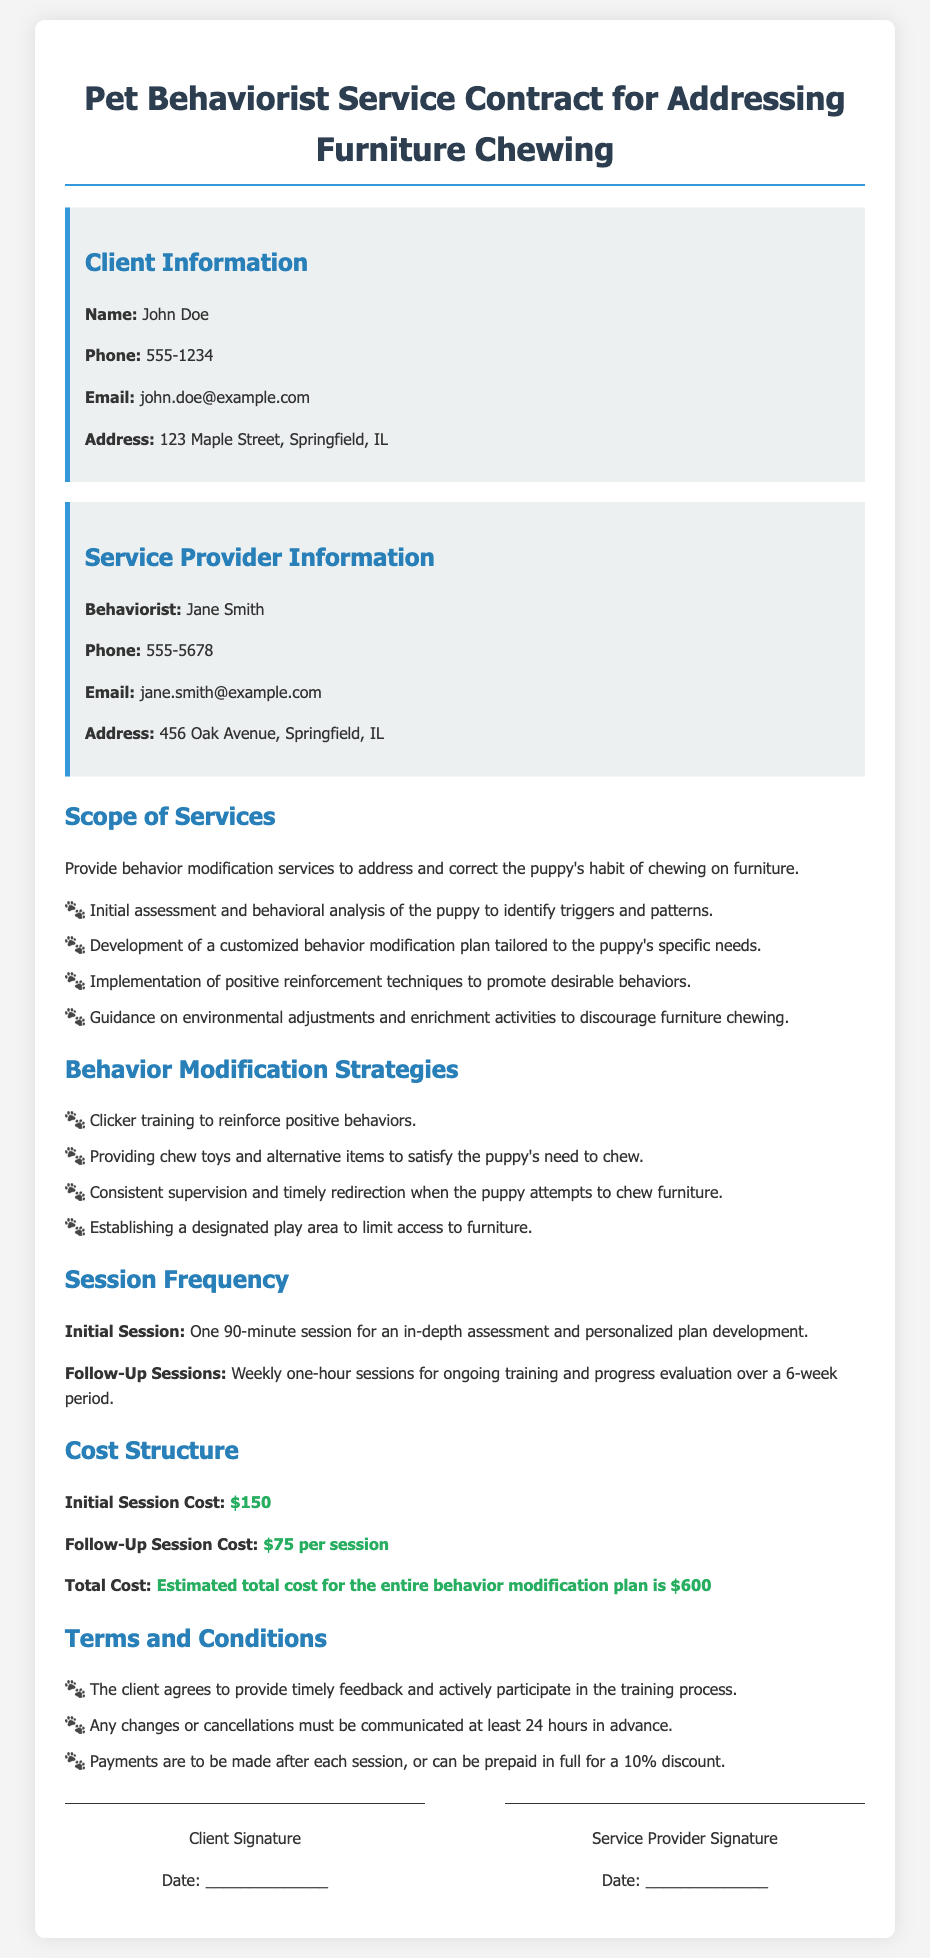What is the name of the client? The client's name is mentioned in the document under Client Information.
Answer: John Doe Who is the service provider? The service provider is listed in the Service Provider Information section of the document.
Answer: Jane Smith How many follow-up sessions are included in the plan? The number of follow-up sessions is specified in the Session Frequency section of the document.
Answer: 6 What is the cost of the initial session? The cost of the initial session is found in the Cost Structure section of the document.
Answer: $150 What type of training method is mentioned for reinforcement? The type of training method used for reinforcement is specified in the Behavior Modification Strategies section.
Answer: Clicker training What must the client do before any changes to the appointment? The document states this requirement under Terms and Conditions.
Answer: Communicate at least 24 hours in advance What is the estimated total cost for the entire behavior modification plan? The total cost is detailed in the Cost Structure section.
Answer: $600 How long is the initial session? The duration of the initial session is mentioned in the Session Frequency section.
Answer: 90 minutes 